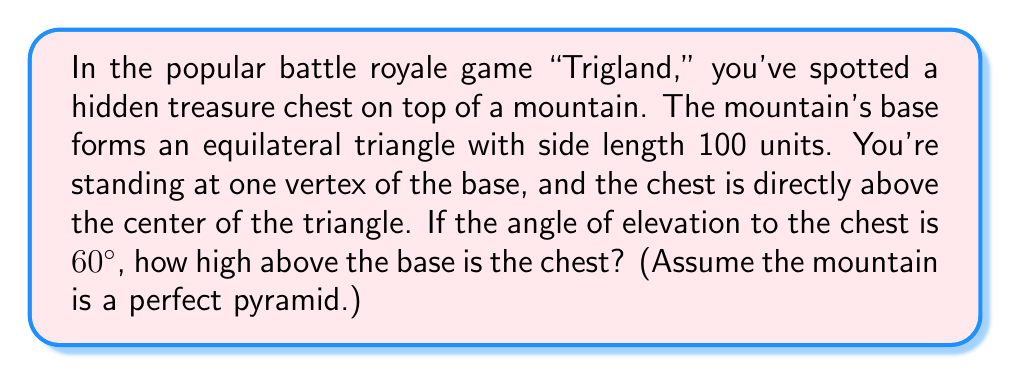Give your solution to this math problem. Let's approach this step-by-step:

1) In an equilateral triangle, the distance from any vertex to the center is equal to $\frac{\sqrt{3}}{3}$ times the side length.

   Side length = 100 units
   Distance to center = $100 \cdot \frac{\sqrt{3}}{3} \approx 57.74$ units

2) We now have a right triangle:
   - The base is the distance from the vertex to the center (57.74 units)
   - The height is what we're looking for
   - The hypotenuse is the line of sight to the chest
   - The angle between the base and hypotenuse is 60°

3) We can use the tangent function to find the height:

   $\tan 60° = \frac{\text{opposite}}{\text{adjacent}} = \frac{\text{height}}{57.74}$

4) We know that $\tan 60° = \sqrt{3}$, so:

   $\sqrt{3} = \frac{\text{height}}{57.74}$

5) Solving for height:

   $\text{height} = 57.74 \cdot \sqrt{3}$

6) Simplifying:

   $\text{height} = 100$

Therefore, the chest is 100 units above the base of the mountain.
Answer: 100 units 